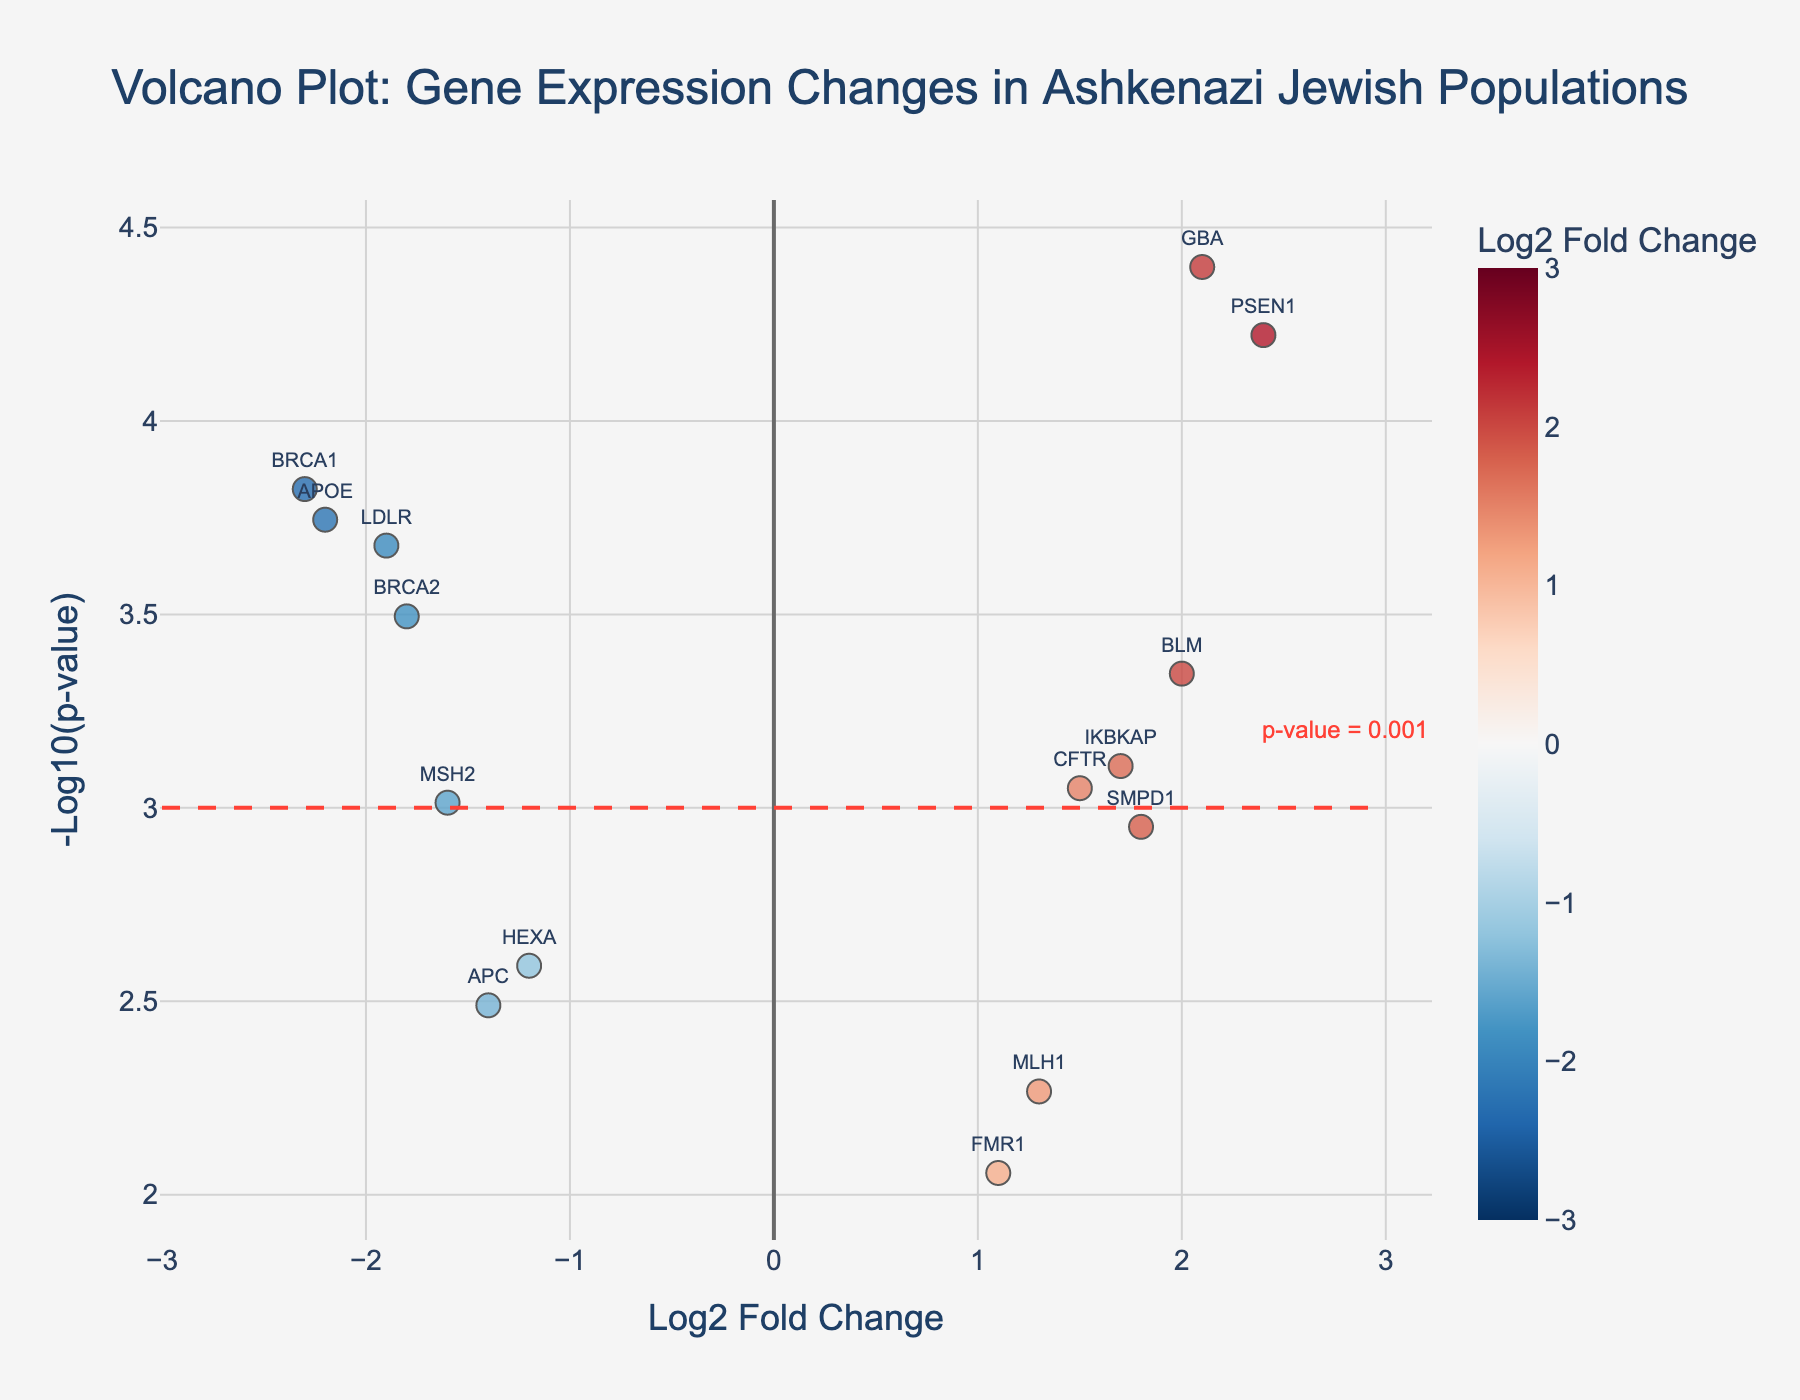What is the title of the plot? The title is prominently displayed at the top of the plot. It reads "Volcano Plot: Gene Expression Changes in Ashkenazi Jewish Populations."
Answer: Volcano Plot: Gene Expression Changes in Ashkenazi Jewish Populations What do the x-axis and y-axis represent in the plot? The x-axis represents the Log2 Fold Change of gene expression, while the y-axis represents the -Log10(p-value) of the data points. This is shown by the axis labels.
Answer: Log2 Fold Change and -Log10(p-value) How many genes have a positive log2 fold change? By examining the points on the right side of the plot (where log2 fold change > 0), we count the number of data points, which are 8 in total, such as CFTR, GBA, etc.
Answer: 8 genes Which gene shows the most significant upregulation? In a volcano plot, upregulation is indicated by a positive log2 fold change. The most significant one would typically have the highest -log10(p-value). Here, PSEN1 has the highest value in the upper right corner.
Answer: PSEN1 Which gene has the lowest p-value? The lowest p-value corresponds to the highest -log10(p-value). The highest point on the y-axis marks the lowest p-value. GBA has the highest y-axis value.
Answer: GBA How is the threshold for significance indicated on the plot? The significance threshold is indicated by a dashed horizontal line on the plot at -log10(p-value) = 3, accompanied by an annotation reading "p-value = 0.001."
Answer: A dashed horizontal line at -log10(p-value) = 3 Which gene has the highest log2 fold change indicating downregulation? Downregulation is shown by a negative log2 fold change. The furthest left point would have the highest absolute value. BRCA1, the leftmost point, has the highest downregulation.
Answer: BRCA1 Compare the significance of BRCA2 and APOE. Both genes have relatively similar log2 fold changes, but significance is measured by -log10(p-value). APOE's -log10(p-value) is higher than that of BRCA2, showing it is more significant.
Answer: APOE is more significant than BRCA2 What does the color of the points on the plot represent? The color of the points in the plot represents the value of the log2 fold change, with a continuous scale from negative to positive, generally using red for negative and blue for positive.
Answer: Log2 fold change Which gene has an approximately equal balance of upregulation and downregulation in the plot? A gene close to the y-axis (horizontal) would indicate an equal balance. Here, HEXA is closest to the y-axis, indicating a smaller magnitude of log2 fold change.
Answer: HEXA 